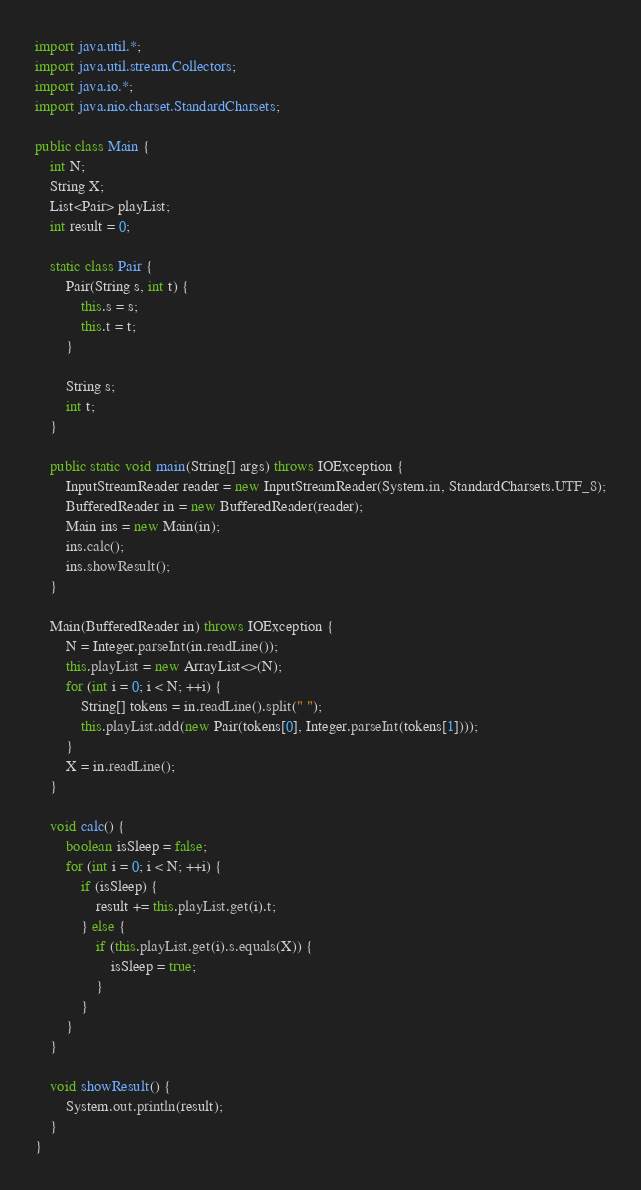Convert code to text. <code><loc_0><loc_0><loc_500><loc_500><_Java_>import java.util.*;
import java.util.stream.Collectors;
import java.io.*;
import java.nio.charset.StandardCharsets;

public class Main {
	int N;
	String X;
	List<Pair> playList;
	int result = 0;

	static class Pair {
		Pair(String s, int t) {
			this.s = s;
			this.t = t;
		}

		String s;
		int t;
	}

	public static void main(String[] args) throws IOException {
		InputStreamReader reader = new InputStreamReader(System.in, StandardCharsets.UTF_8);
		BufferedReader in = new BufferedReader(reader);
		Main ins = new Main(in);
		ins.calc();
		ins.showResult();
	}

	Main(BufferedReader in) throws IOException {
		N = Integer.parseInt(in.readLine());
		this.playList = new ArrayList<>(N);
		for (int i = 0; i < N; ++i) {
			String[] tokens = in.readLine().split(" ");
			this.playList.add(new Pair(tokens[0], Integer.parseInt(tokens[1])));
		}
		X = in.readLine();
	}

	void calc() {
		boolean isSleep = false;
		for (int i = 0; i < N; ++i) {
			if (isSleep) {
				result += this.playList.get(i).t;
			} else {
				if (this.playList.get(i).s.equals(X)) {
					isSleep = true;
				}
			}
		}
	}

	void showResult() {
		System.out.println(result);
	}
}
</code> 